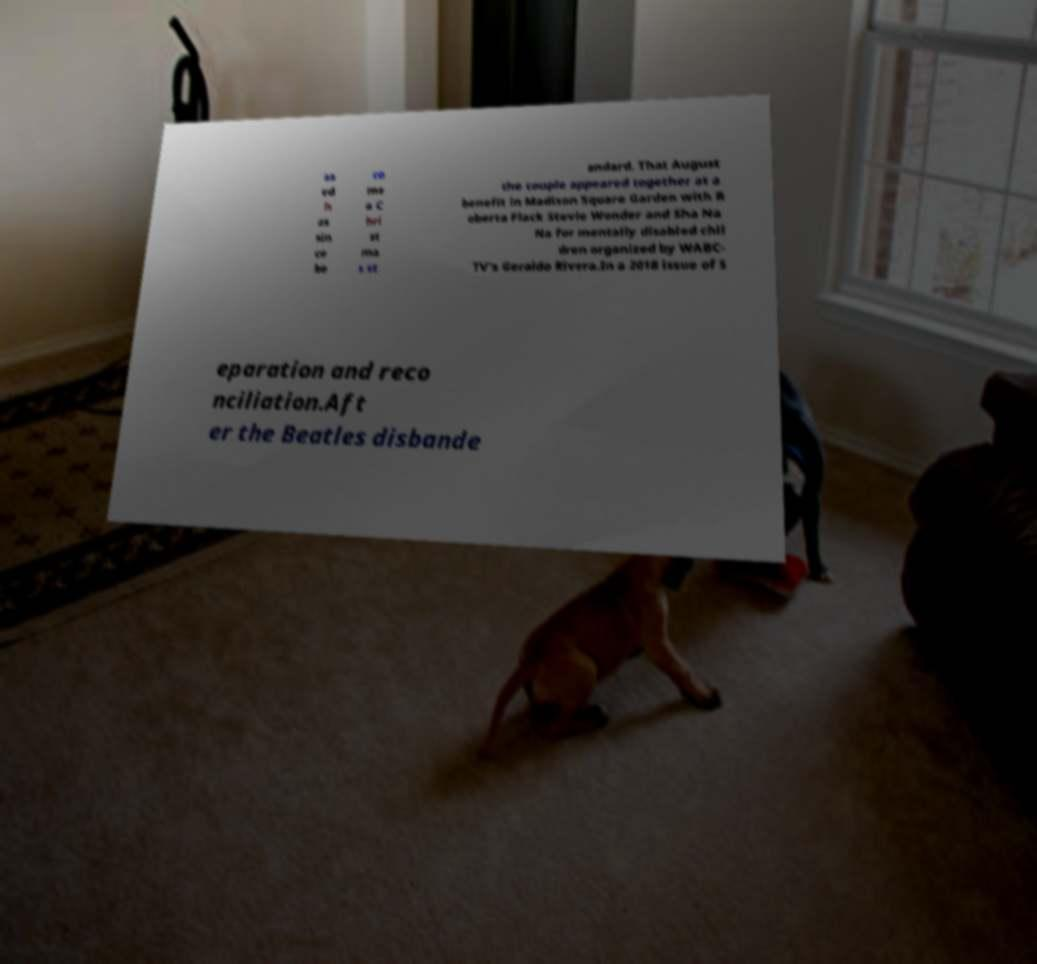Could you extract and type out the text from this image? as ed h as sin ce be co me a C hri st ma s st andard. That August the couple appeared together at a benefit in Madison Square Garden with R oberta Flack Stevie Wonder and Sha Na Na for mentally disabled chil dren organized by WABC- TV's Geraldo Rivera.In a 2018 issue of S eparation and reco nciliation.Aft er the Beatles disbande 